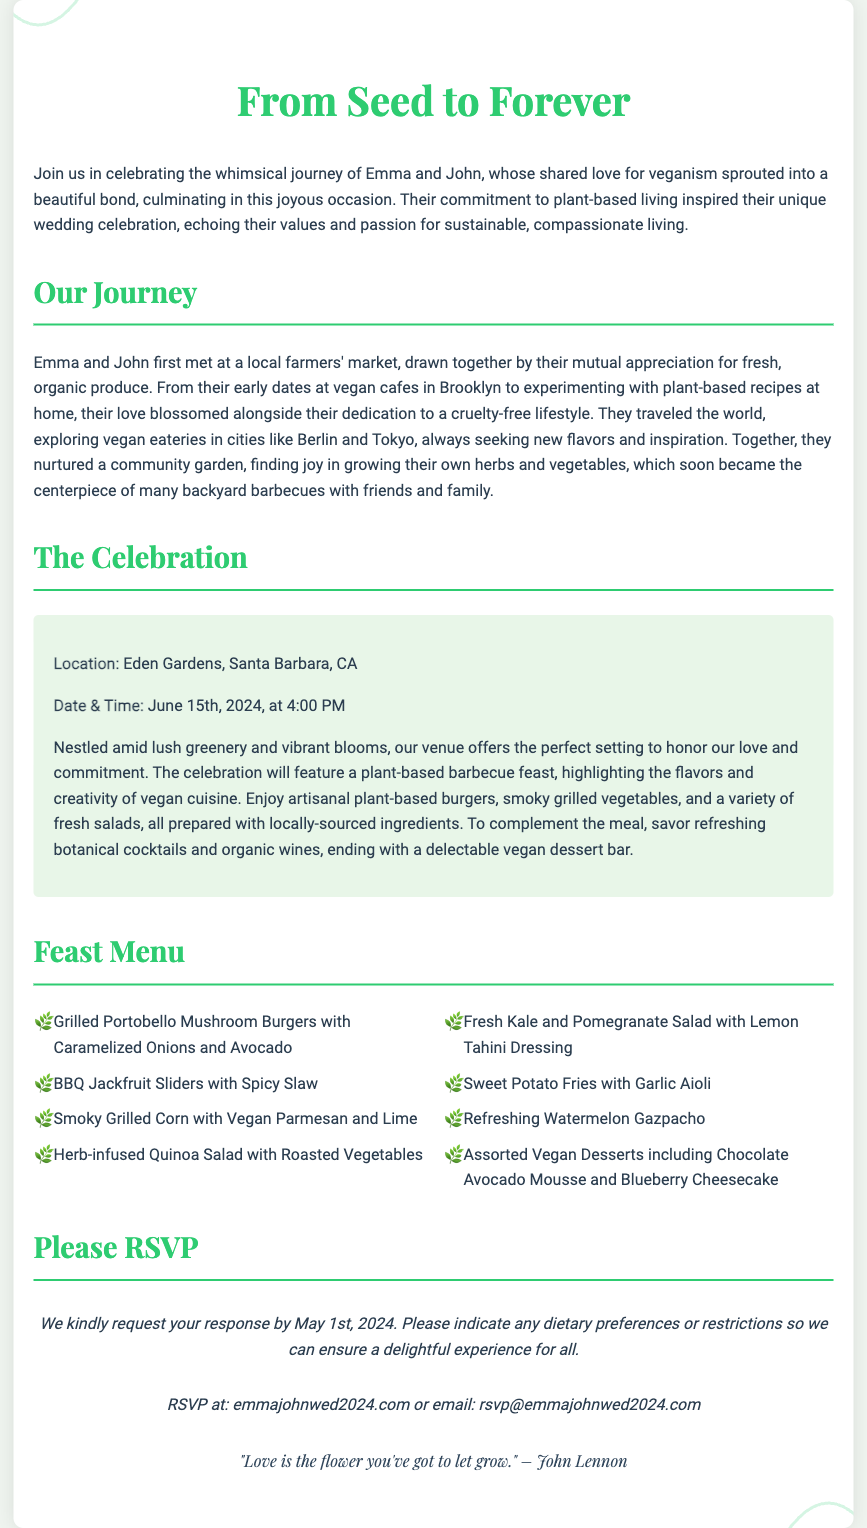What is the title of the wedding invitation? The title is prominently displayed at the top of the invitation and reads "From Seed to Forever."
Answer: From Seed to Forever When is the wedding date? The wedding date is mentioned in the details section of the invitation and states June 15th, 2024.
Answer: June 15th, 2024 Where is the wedding ceremony taking place? The location of the wedding is indicated in the event details, specifying Eden Gardens, Santa Barbara, CA.
Answer: Eden Gardens, Santa Barbara, CA What type of cuisine will be served at the wedding? The wedding will feature a plant-based barbecue feast, which is also highlighted in the paragraph describing the celebration.
Answer: Plant-based barbecue What are the names of the couple getting married? The couple's names are mentioned at the top of the invitation in the introductory paragraph, listing "Emma and John."
Answer: Emma and John What is the RSVP deadline? The RSVP deadline is stated in the invitation, requesting a response by May 1st, 2024.
Answer: May 1st, 2024 What is a unique aspect of Emma and John's journey? The invitation describes their love blossoming alongside their dedication to veganism, shared experiences, and community gardening.
Answer: Dedication to veganism Which dessert is included in the vegan dessert bar? The feast menu lists several desserts, including "Chocolate Avocado Mousse."
Answer: Chocolate Avocado Mousse What is quoted at the end of the invitation? A quote is provided at the bottom of the invitation, attributed to John Lennon about love.
Answer: "Love is the flower you've got to let grow." – John Lennon 